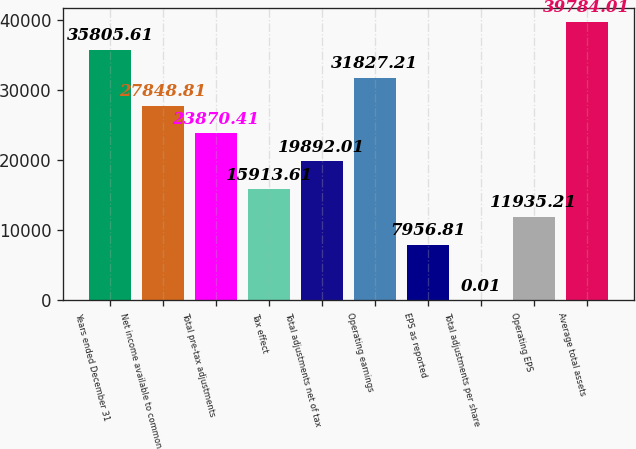Convert chart to OTSL. <chart><loc_0><loc_0><loc_500><loc_500><bar_chart><fcel>Years ended December 31<fcel>Net income available to common<fcel>Total pre-tax adjustments<fcel>Tax effect<fcel>Total adjustments net of tax<fcel>Operating earnings<fcel>EPS as reported<fcel>Total adjustments per share<fcel>Operating EPS<fcel>Average total assets<nl><fcel>35805.6<fcel>27848.8<fcel>23870.4<fcel>15913.6<fcel>19892<fcel>31827.2<fcel>7956.81<fcel>0.01<fcel>11935.2<fcel>39784<nl></chart> 